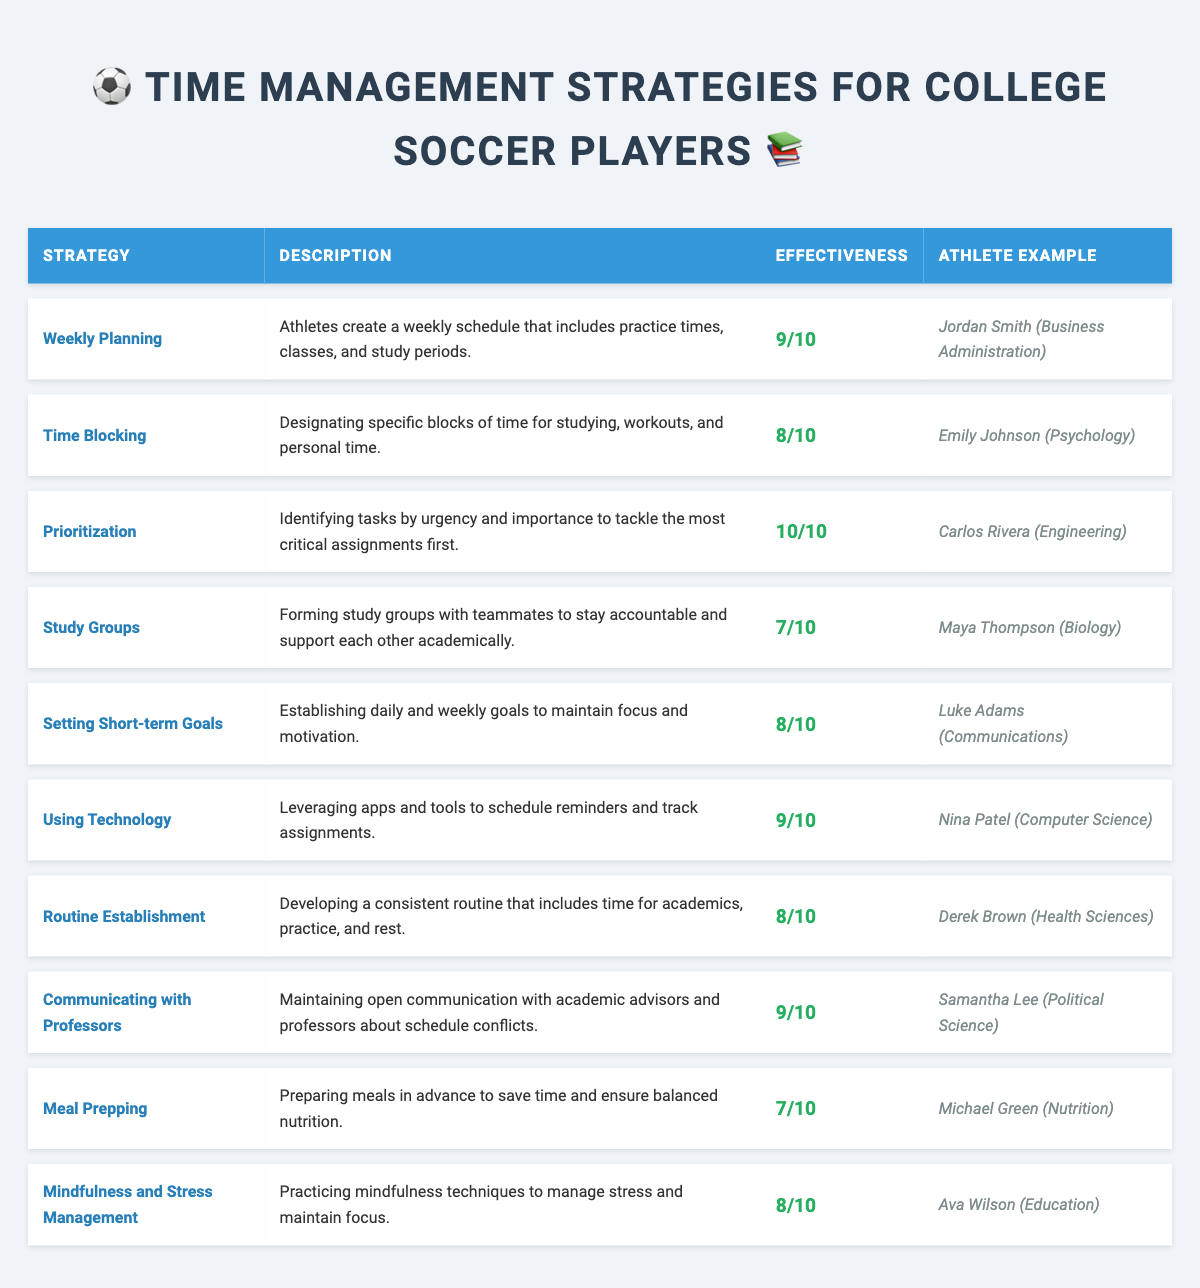What is the effectiveness rating of "Prioritization"? The effectiveness rating for "Prioritization" is listed directly in the table and is indicated as 10/10.
Answer: 10/10 Which athlete uses "Weekly Planning" as their time management strategy? The table lists "Jordan Smith" as the athlete associated with the "Weekly Planning" strategy.
Answer: Jordan Smith How many strategies have an effectiveness rating of 9 or above? By reviewing the effectiveness ratings in the table, there are four strategies rated 9/10 or higher: "Prioritization," "Weekly Planning," "Using Technology," and "Communicating with Professors."
Answer: 4 What is the average effectiveness rating of the strategies listed in the table? To find the average, add the effectiveness ratings (9 + 8 + 10 + 7 + 8 + 9 + 8 + 9 + 7 + 8 = 81), and then divide by the number of strategies (10). Therefore, the average is 81/10 = 8.1.
Answer: 8.1 True or False: "Study Groups" has a higher effectiveness rating than "Meal Prepping." By checking the table, "Study Groups" has a rating of 7/10 while "Meal Prepping" also has a rating of 7/10. Since they are equal, the statement is false.
Answer: False Which athlete is pursuing a major in "Computer Science"? The table indicates that "Nina Patel" is the athlete majoring in "Computer Science" and is using the "Using Technology" strategy.
Answer: Nina Patel What is the most effective strategy based on the ratings? The strategy "Prioritization" has the highest effectiveness rating at 10/10, making it the most effective strategy according to the table.
Answer: Prioritization If Maya Thompson improves her strategy rating to 9, what would the new average rating be? First, add the current ratings (81 total) and add Maya's new rating (9), making it 81 + 2 = 83. Then, divide by 10 (the total number of strategies), resulting in 83/10 = 8.3.
Answer: 8.3 Which major is associated with "Derek Brown"? According to the table, "Derek Brown" is associated with the major "Health Sciences."
Answer: Health Sciences What is the difference in effectiveness ratings between "Time Blocking" and "Meal Prepping"? "Time Blocking" has an effectiveness rating of 8, while "Meal Prepping" has a rating of 7. The difference is calculated by subtracting the two ratings, giving us 8 - 7 = 1.
Answer: 1 